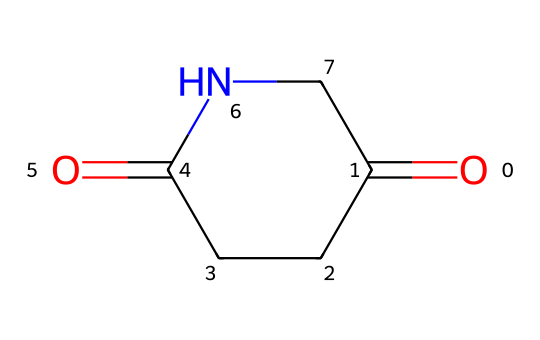What is the molecular formula of glutarimide? The SMILES representation indicates the presence of carbon, hydrogen, nitrogen, and oxygen atoms. Count the respective atoms in the structure to derive the formula: there are 5 carbons, 7 hydrogens, 1 nitrogen, and 2 oxygens. Therefore, the molecular formula is C5H7N1O2.
Answer: C5H7NO2 How many rings are present in glutarimide? Analyzing the structure, glutarimide has one cyclic structure formed by the nitrogen and carbon atoms connecting back to themselves. This is evident in the arrangement that forms a six-membered ring.
Answer: 1 Identify the functional groups in glutarimide. By reviewing the SMILES representation, we see the presence of a carbonyl group (C=O) and an amide group (N-C=O) indicating that it contains these functional groups characteristic of imides.
Answer: carbonyl and amide What type of reaction can glutarimide undergo due to its structure? The cyclic structure of glutarimide, along with the carbonyl groups, allows it to participate in ring-opening reactions and hydrolysis, typical behavior of imides.
Answer: ring-opening reactions How does glutarimide contribute to mood-altering properties? The nitrogen atom hints at the potential to interact with neurotransmitter systems in the brain. The molecular structure may also influence the compound's ability to modulate mood-relevant pathways, affecting neurotransmitter release.
Answer: neurotransmitter interaction What role does the nitrogen atom play in glutarimide's chemical behavior? The nitrogen atom is part of the amide bond, which imparts basicity to the compound, allowing it to interact more readily with acids and serve as a potential site for hydrogen bonding in biological systems.
Answer: basicity and hydrogen bonding What is the significance of the C=O bond in glutarimide's reactivity? The C=O bond is a defining characteristic of imides. It is reactive and can participate in nucleophilic addition reactions, contributing to the stability and reactivity of the compound within biological systems.
Answer: reactivity and nucleophilic addition 